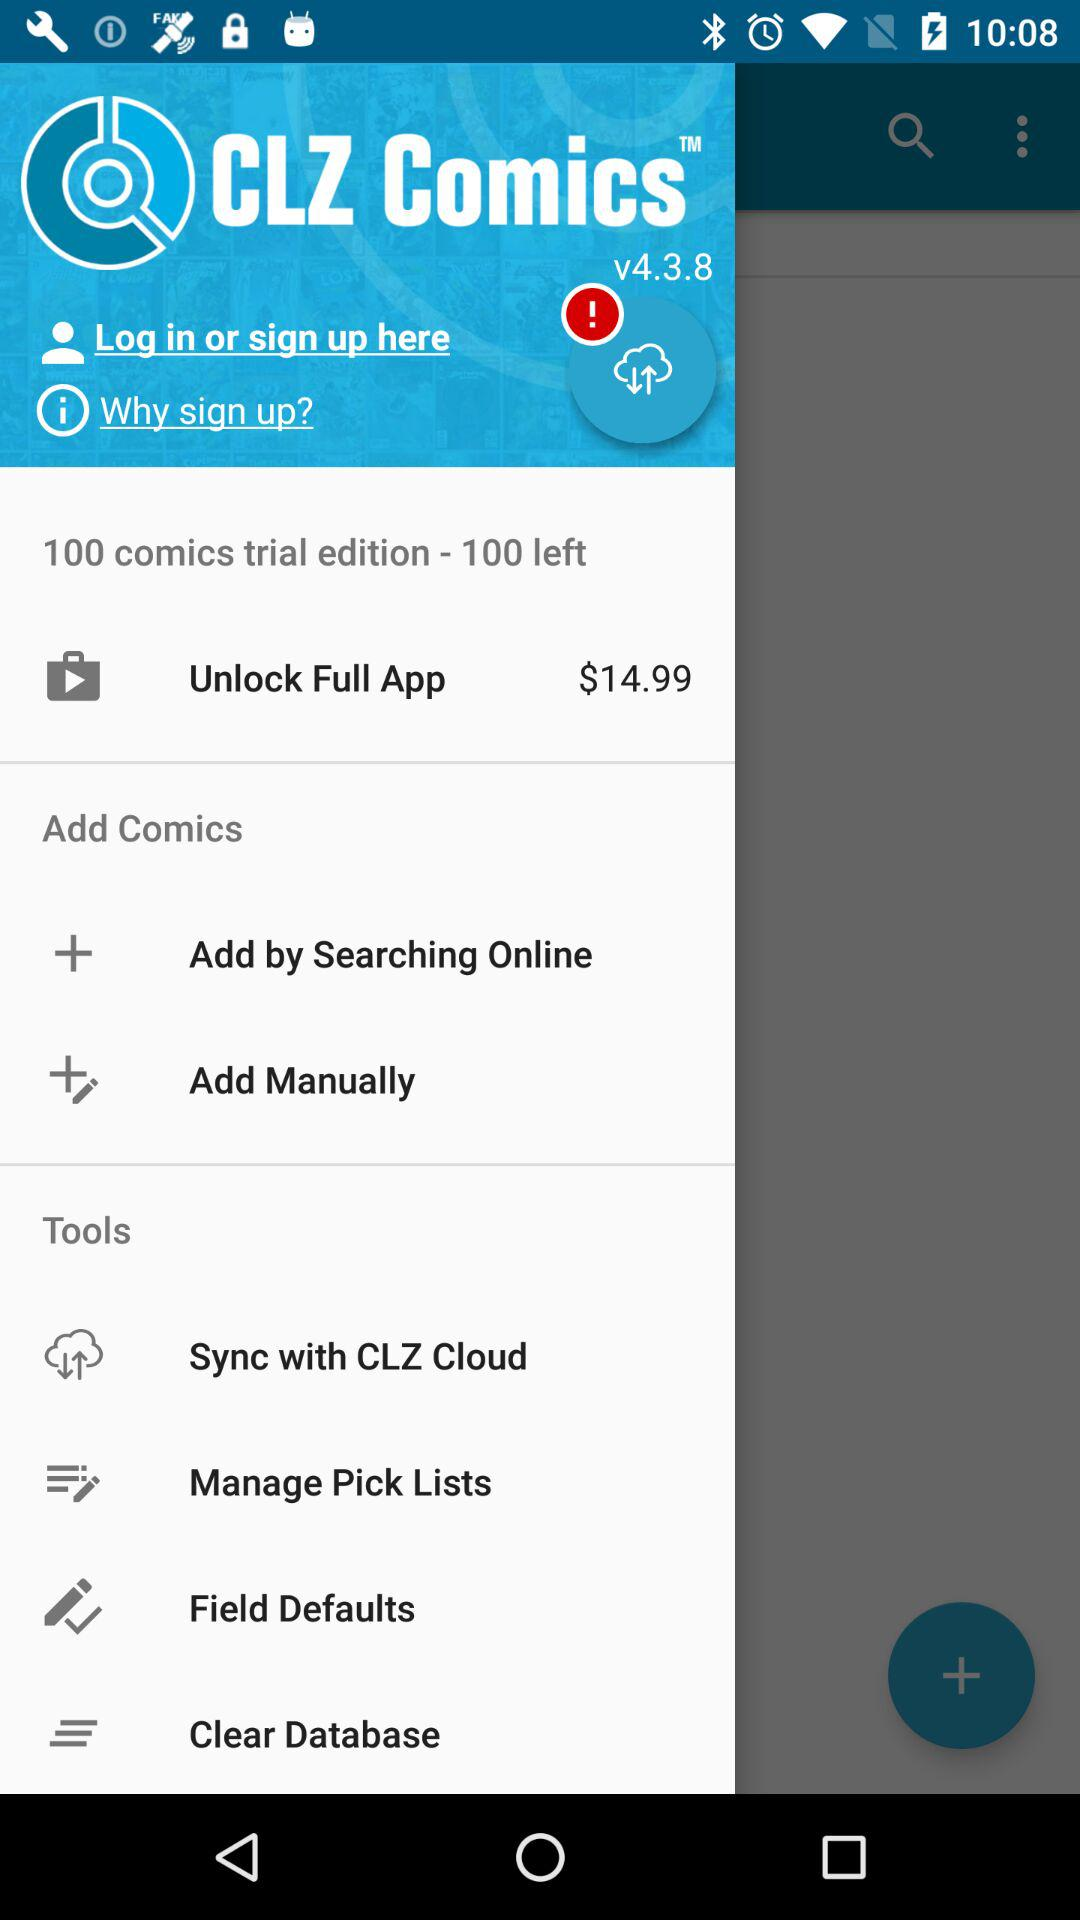How much does it cost to unlock the full app? It costs $14.99 to unlock the full app. 